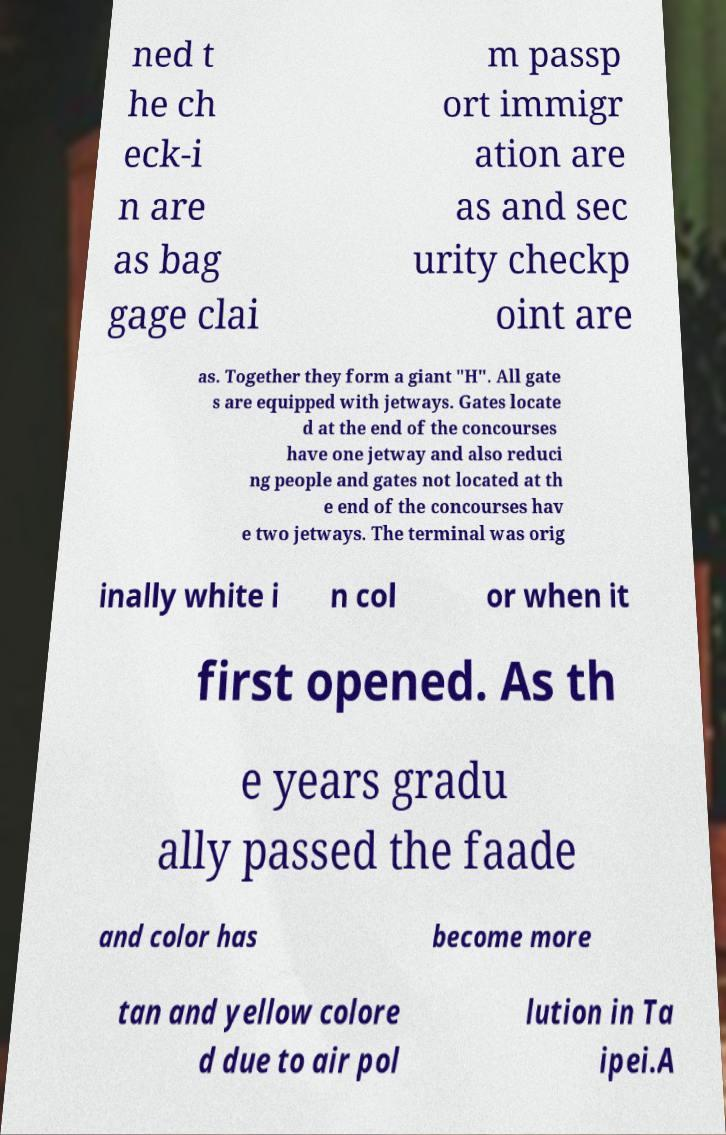Could you extract and type out the text from this image? ned t he ch eck-i n are as bag gage clai m passp ort immigr ation are as and sec urity checkp oint are as. Together they form a giant "H". All gate s are equipped with jetways. Gates locate d at the end of the concourses have one jetway and also reduci ng people and gates not located at th e end of the concourses hav e two jetways. The terminal was orig inally white i n col or when it first opened. As th e years gradu ally passed the faade and color has become more tan and yellow colore d due to air pol lution in Ta ipei.A 